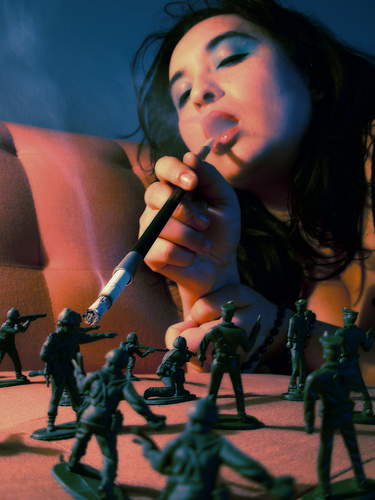<image>
Can you confirm if the statue is under the smoke? Yes. The statue is positioned underneath the smoke, with the smoke above it in the vertical space. 